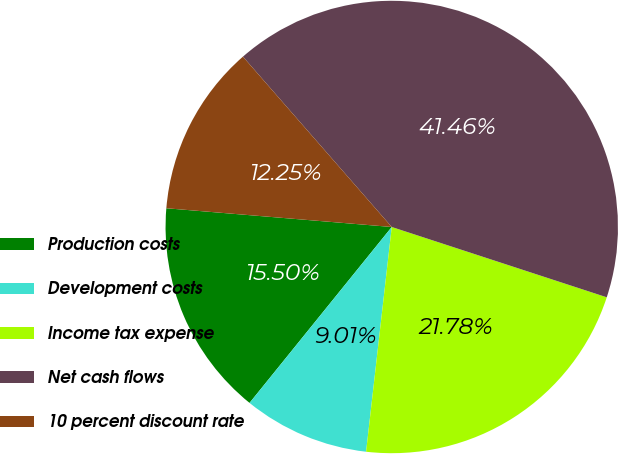Convert chart to OTSL. <chart><loc_0><loc_0><loc_500><loc_500><pie_chart><fcel>Production costs<fcel>Development costs<fcel>Income tax expense<fcel>Net cash flows<fcel>10 percent discount rate<nl><fcel>15.5%<fcel>9.01%<fcel>21.78%<fcel>41.46%<fcel>12.25%<nl></chart> 